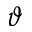Convert formula to latex. <formula><loc_0><loc_0><loc_500><loc_500>\vartheta</formula> 